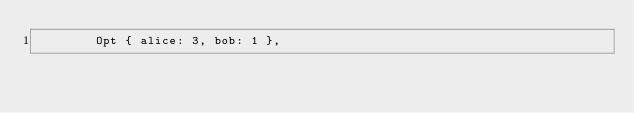Convert code to text. <code><loc_0><loc_0><loc_500><loc_500><_Rust_>        Opt { alice: 3, bob: 1 },</code> 